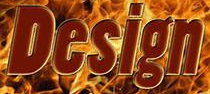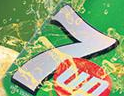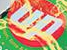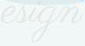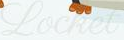What words are shown in these images in order, separated by a semicolon? Design; 7; up; esign; Locket 